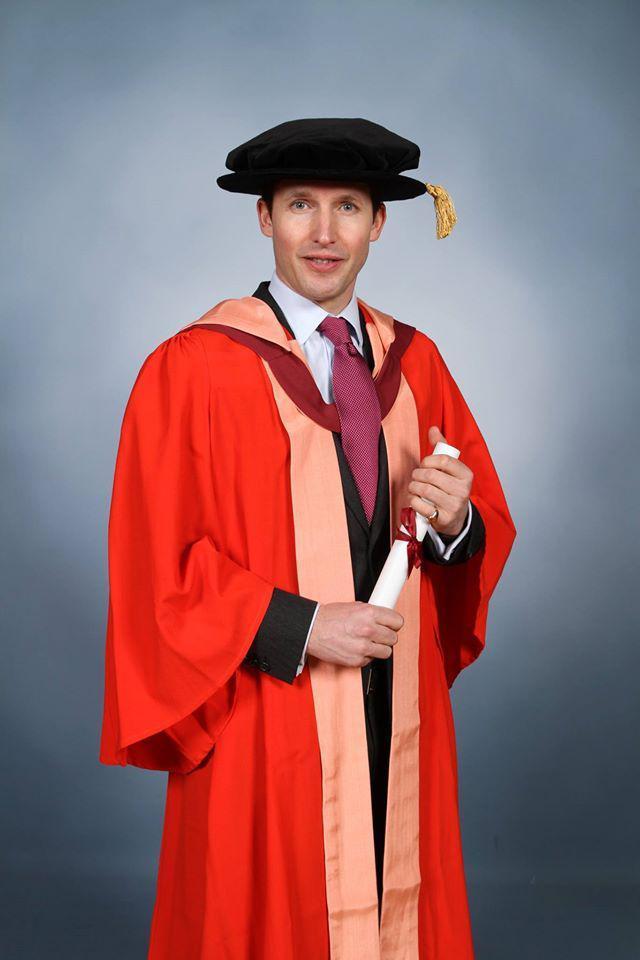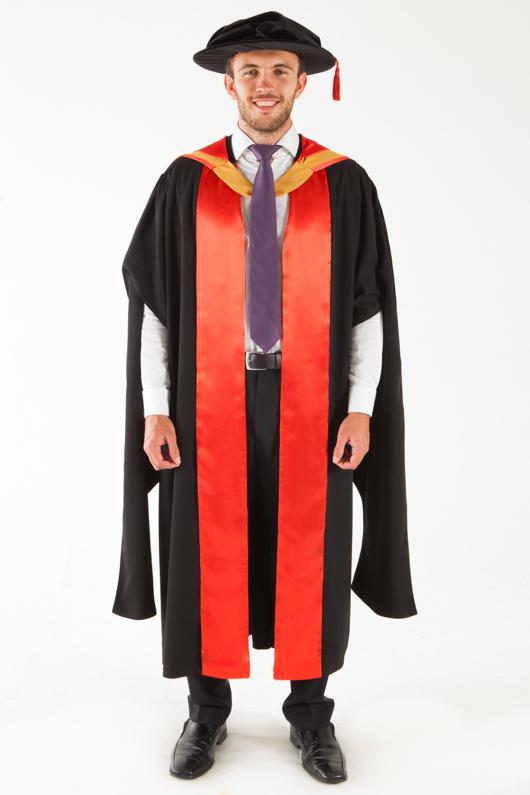The first image is the image on the left, the second image is the image on the right. Assess this claim about the two images: "The image on the left shows a student in graduation attire holding a diploma in their hands.". Correct or not? Answer yes or no. Yes. 